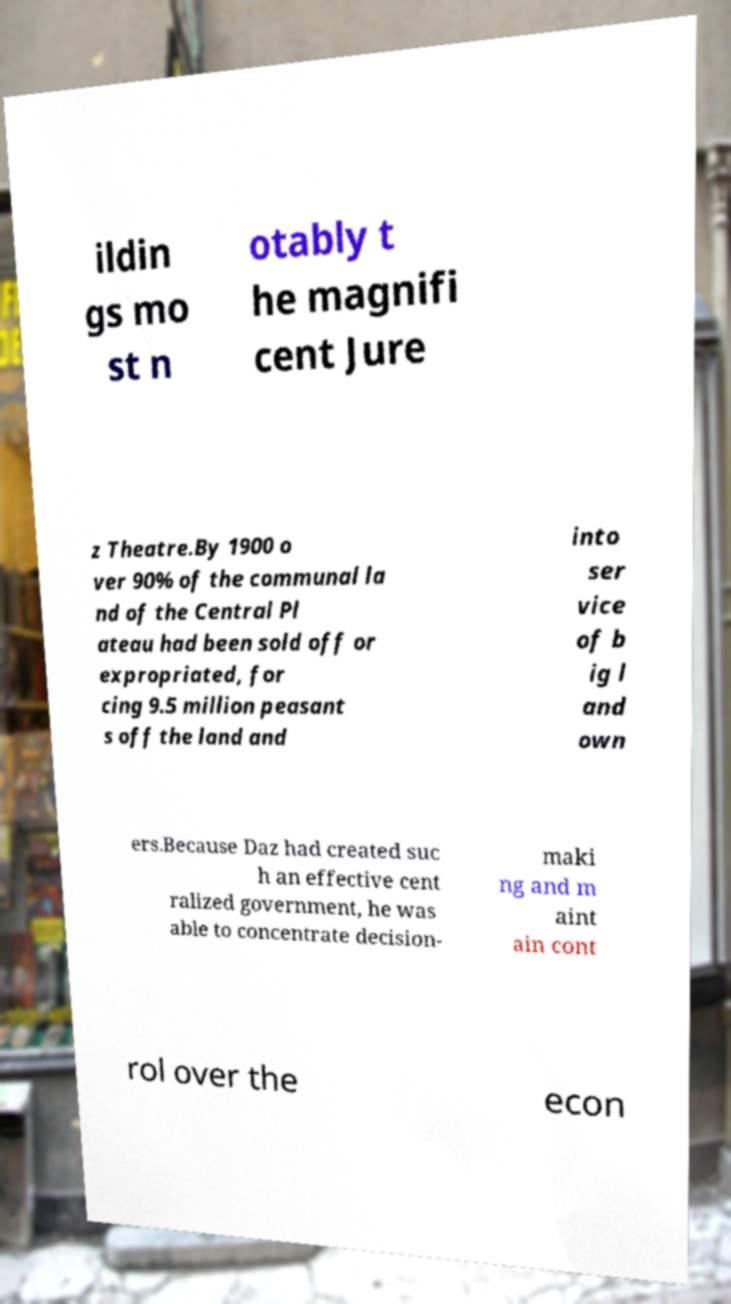Could you assist in decoding the text presented in this image and type it out clearly? ildin gs mo st n otably t he magnifi cent Jure z Theatre.By 1900 o ver 90% of the communal la nd of the Central Pl ateau had been sold off or expropriated, for cing 9.5 million peasant s off the land and into ser vice of b ig l and own ers.Because Daz had created suc h an effective cent ralized government, he was able to concentrate decision- maki ng and m aint ain cont rol over the econ 